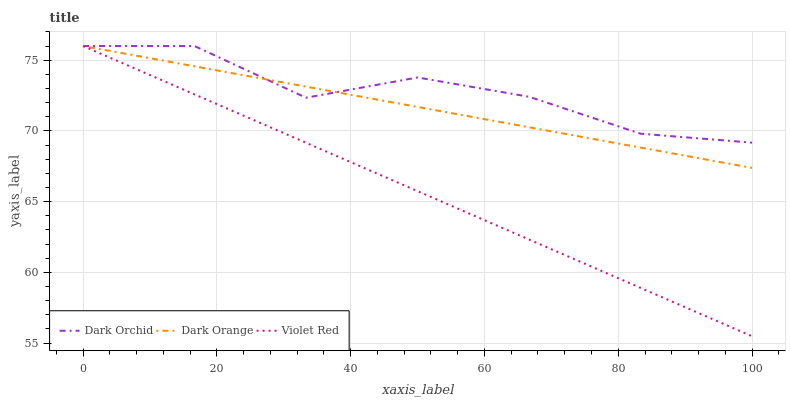Does Violet Red have the minimum area under the curve?
Answer yes or no. Yes. Does Dark Orchid have the maximum area under the curve?
Answer yes or no. Yes. Does Dark Orchid have the minimum area under the curve?
Answer yes or no. No. Does Violet Red have the maximum area under the curve?
Answer yes or no. No. Is Violet Red the smoothest?
Answer yes or no. Yes. Is Dark Orchid the roughest?
Answer yes or no. Yes. Is Dark Orchid the smoothest?
Answer yes or no. No. Is Violet Red the roughest?
Answer yes or no. No. Does Violet Red have the lowest value?
Answer yes or no. Yes. Does Dark Orchid have the lowest value?
Answer yes or no. No. Does Dark Orchid have the highest value?
Answer yes or no. Yes. Does Violet Red intersect Dark Orange?
Answer yes or no. Yes. Is Violet Red less than Dark Orange?
Answer yes or no. No. Is Violet Red greater than Dark Orange?
Answer yes or no. No. 